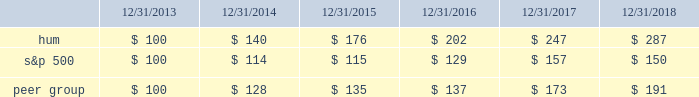Stock total return performance the following graph compares our total return to stockholders with the returns of the standard & poor 2019s composite 500 index ( 201cs&p 500 201d ) and the dow jones us select health care providers index ( 201cpeer group 201d ) for the five years ended december 31 , 2018 .
The graph assumes an investment of $ 100 in each of our common stock , the s&p 500 , and the peer group on december 31 , 2013 , and that dividends were reinvested when paid. .
The stock price performance included in this graph is not necessarily indicative of future stock price performance. .
What is the lowest return for the first year of investment? 
Rationale: it is the minimum value for the first year of the investment , then turned into a percentage to represent the return .
Computations: (114 - 100)
Answer: 14.0. 